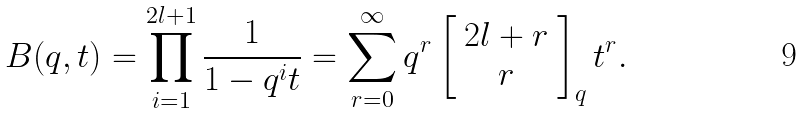<formula> <loc_0><loc_0><loc_500><loc_500>B ( q , t ) = \prod _ { i = 1 } ^ { 2 l + 1 } \frac { 1 } { 1 - q ^ { i } t } = \sum _ { r = 0 } ^ { \infty } q ^ { r } \left [ \begin{array} { c } 2 l + r \\ r \end{array} \right ] _ { q } t ^ { r } .</formula> 